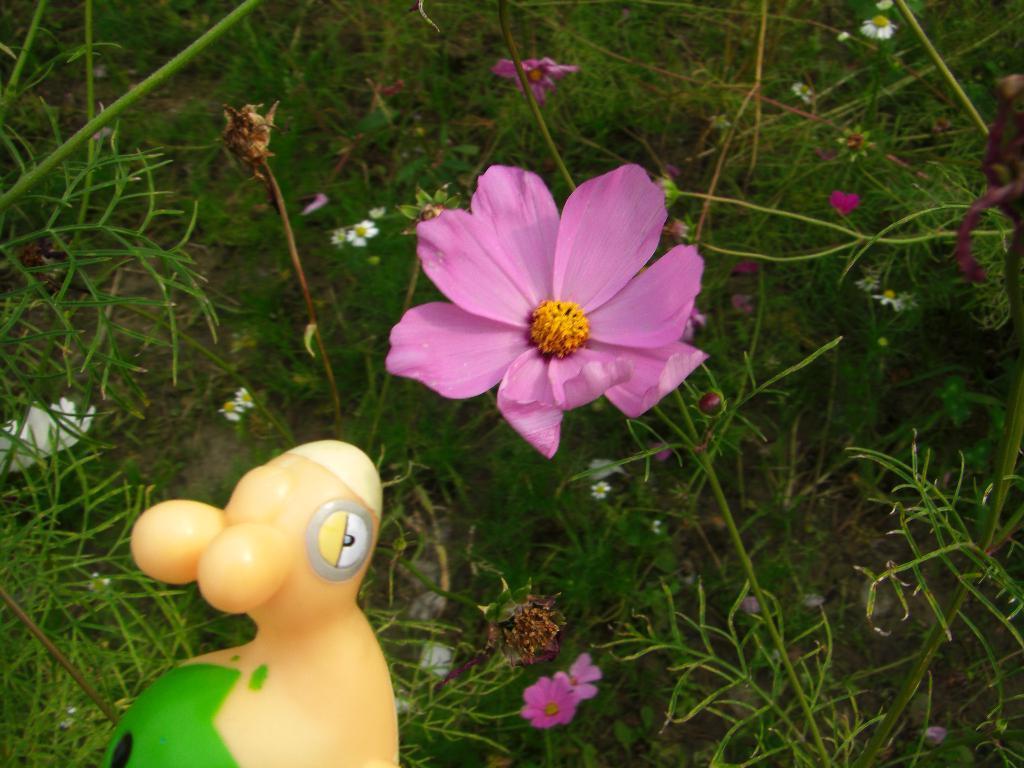How would you summarize this image in a sentence or two? In this image we can see one toy, some different plants with different flowers and some grass on the ground. 